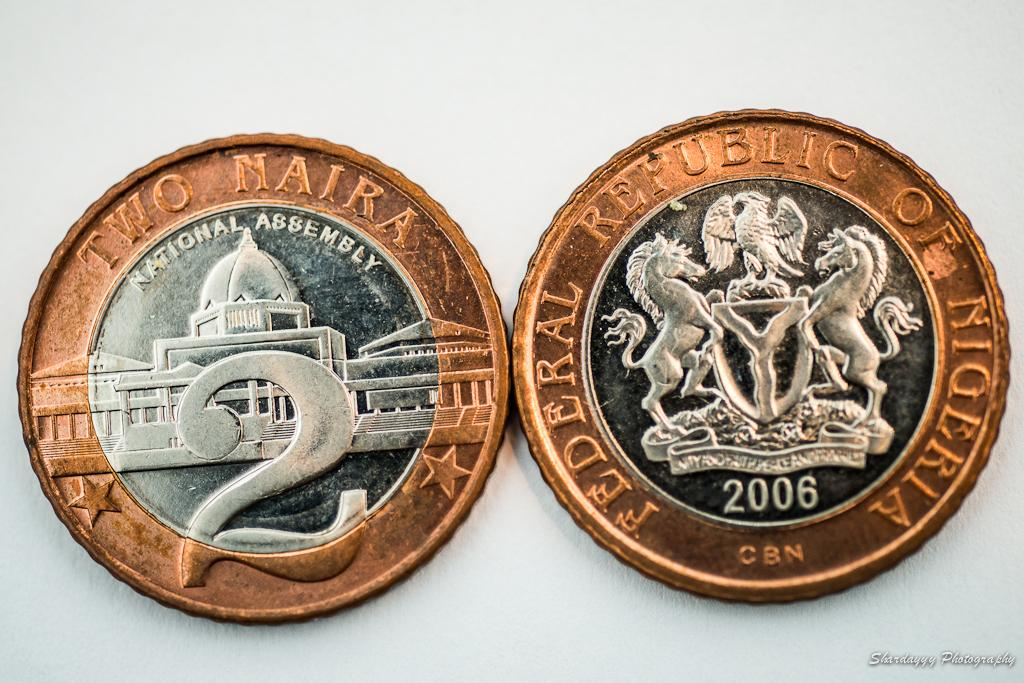<image>
Present a compact description of the photo's key features. Two coins are adjacent to each other with one including the text National Assembly. 